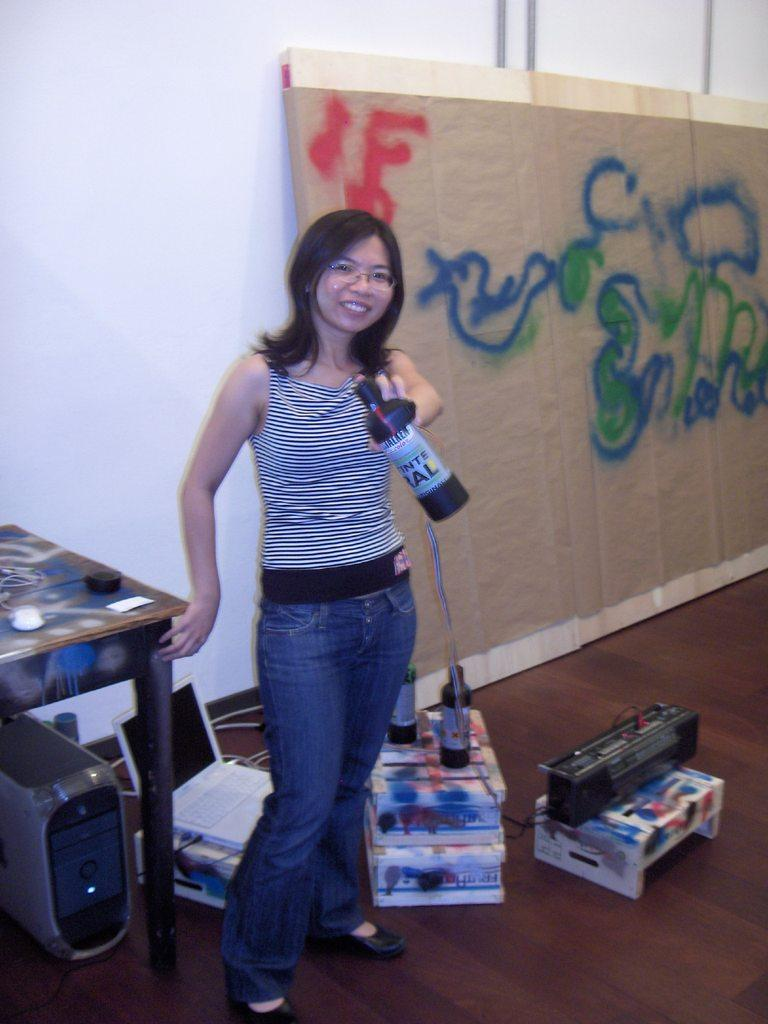Who is present in the image? There is a woman in the image. What is the woman holding in the image? The woman is holding a bottle. How many bottles can be seen in the image? There are bottles visible in the image. What other objects can be seen in the image? There are boxes, a table, a laptop, a sound system, and a board on the wall in the image. What type of food is being served at the club in the image? There is no club or food present in the image. The image features a woman holding a bottle, boxes, a table, a laptop, a sound system, and a board on the wall. 